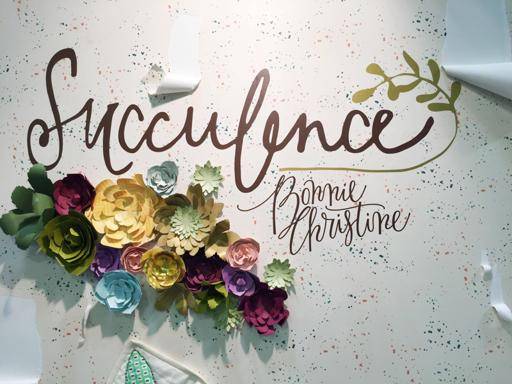Can you tell me more about the style of writing used in the image? The style of writing in the image is a cursive script, which is both graceful and fluid. It's often used for decorative purposes to convey elegance and personal touch, likely chosen here to enhance the aesthetic appeal of the decoration. What might be the purpose of such a decoration? This type of decoration is often used in events such as weddings, baby showers, or boutique retail spaces. It's meant to add a personal and artistic touch to the environment, often reflecting the theme or celebrating a specific person or occasion. 